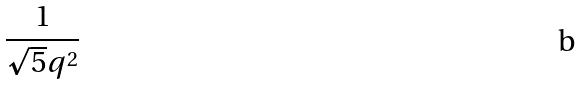<formula> <loc_0><loc_0><loc_500><loc_500>\frac { 1 } { \sqrt { 5 } q ^ { 2 } }</formula> 